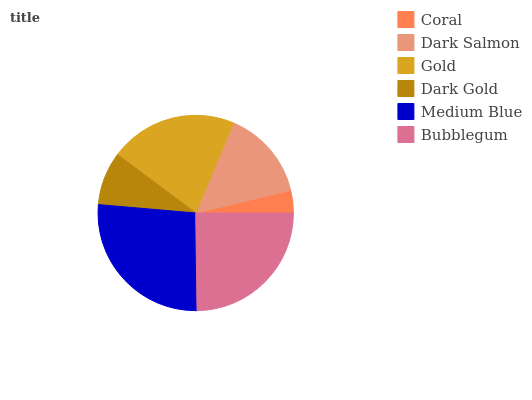Is Coral the minimum?
Answer yes or no. Yes. Is Medium Blue the maximum?
Answer yes or no. Yes. Is Dark Salmon the minimum?
Answer yes or no. No. Is Dark Salmon the maximum?
Answer yes or no. No. Is Dark Salmon greater than Coral?
Answer yes or no. Yes. Is Coral less than Dark Salmon?
Answer yes or no. Yes. Is Coral greater than Dark Salmon?
Answer yes or no. No. Is Dark Salmon less than Coral?
Answer yes or no. No. Is Gold the high median?
Answer yes or no. Yes. Is Dark Salmon the low median?
Answer yes or no. Yes. Is Dark Salmon the high median?
Answer yes or no. No. Is Gold the low median?
Answer yes or no. No. 